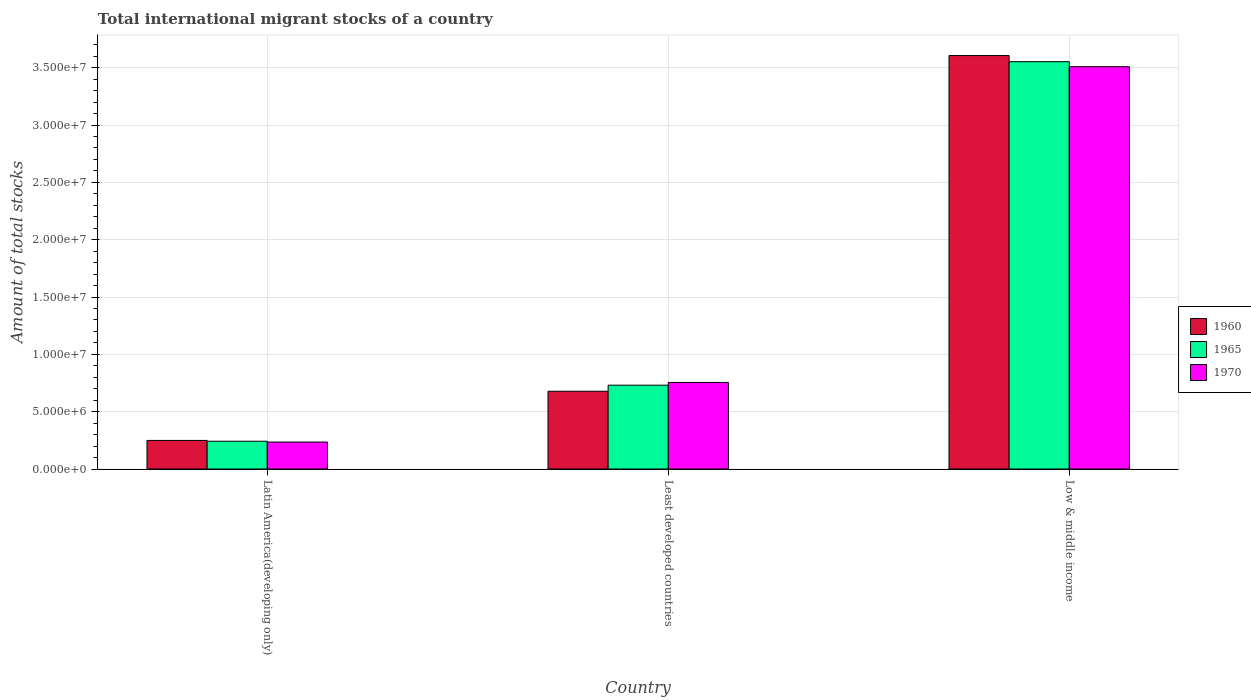Are the number of bars on each tick of the X-axis equal?
Keep it short and to the point. Yes. What is the label of the 1st group of bars from the left?
Provide a short and direct response. Latin America(developing only). What is the amount of total stocks in in 1960 in Least developed countries?
Ensure brevity in your answer.  6.78e+06. Across all countries, what is the maximum amount of total stocks in in 1965?
Ensure brevity in your answer.  3.55e+07. Across all countries, what is the minimum amount of total stocks in in 1960?
Make the answer very short. 2.49e+06. In which country was the amount of total stocks in in 1970 maximum?
Your response must be concise. Low & middle income. In which country was the amount of total stocks in in 1965 minimum?
Provide a succinct answer. Latin America(developing only). What is the total amount of total stocks in in 1960 in the graph?
Provide a succinct answer. 4.53e+07. What is the difference between the amount of total stocks in in 1970 in Latin America(developing only) and that in Least developed countries?
Your response must be concise. -5.20e+06. What is the difference between the amount of total stocks in in 1965 in Low & middle income and the amount of total stocks in in 1970 in Latin America(developing only)?
Keep it short and to the point. 3.32e+07. What is the average amount of total stocks in in 1970 per country?
Your answer should be compact. 1.50e+07. What is the difference between the amount of total stocks in of/in 1965 and amount of total stocks in of/in 1970 in Low & middle income?
Keep it short and to the point. 4.38e+05. In how many countries, is the amount of total stocks in in 1960 greater than 15000000?
Give a very brief answer. 1. What is the ratio of the amount of total stocks in in 1965 in Least developed countries to that in Low & middle income?
Provide a short and direct response. 0.21. Is the amount of total stocks in in 1965 in Least developed countries less than that in Low & middle income?
Your answer should be compact. Yes. Is the difference between the amount of total stocks in in 1965 in Latin America(developing only) and Low & middle income greater than the difference between the amount of total stocks in in 1970 in Latin America(developing only) and Low & middle income?
Ensure brevity in your answer.  No. What is the difference between the highest and the second highest amount of total stocks in in 1970?
Keep it short and to the point. -2.75e+07. What is the difference between the highest and the lowest amount of total stocks in in 1960?
Offer a terse response. 3.36e+07. Is the sum of the amount of total stocks in in 1965 in Latin America(developing only) and Least developed countries greater than the maximum amount of total stocks in in 1960 across all countries?
Make the answer very short. No. What does the 2nd bar from the left in Low & middle income represents?
Offer a very short reply. 1965. Is it the case that in every country, the sum of the amount of total stocks in in 1970 and amount of total stocks in in 1965 is greater than the amount of total stocks in in 1960?
Make the answer very short. Yes. How many countries are there in the graph?
Your answer should be compact. 3. Does the graph contain any zero values?
Your response must be concise. No. What is the title of the graph?
Provide a succinct answer. Total international migrant stocks of a country. Does "1987" appear as one of the legend labels in the graph?
Your answer should be very brief. No. What is the label or title of the Y-axis?
Your answer should be very brief. Amount of total stocks. What is the Amount of total stocks of 1960 in Latin America(developing only)?
Your answer should be very brief. 2.49e+06. What is the Amount of total stocks of 1965 in Latin America(developing only)?
Your response must be concise. 2.42e+06. What is the Amount of total stocks in 1970 in Latin America(developing only)?
Your answer should be very brief. 2.35e+06. What is the Amount of total stocks of 1960 in Least developed countries?
Your answer should be compact. 6.78e+06. What is the Amount of total stocks in 1965 in Least developed countries?
Your answer should be very brief. 7.31e+06. What is the Amount of total stocks in 1970 in Least developed countries?
Your answer should be very brief. 7.55e+06. What is the Amount of total stocks of 1960 in Low & middle income?
Offer a terse response. 3.61e+07. What is the Amount of total stocks of 1965 in Low & middle income?
Keep it short and to the point. 3.55e+07. What is the Amount of total stocks in 1970 in Low & middle income?
Offer a terse response. 3.51e+07. Across all countries, what is the maximum Amount of total stocks in 1960?
Your response must be concise. 3.61e+07. Across all countries, what is the maximum Amount of total stocks of 1965?
Offer a terse response. 3.55e+07. Across all countries, what is the maximum Amount of total stocks of 1970?
Your answer should be very brief. 3.51e+07. Across all countries, what is the minimum Amount of total stocks in 1960?
Your answer should be very brief. 2.49e+06. Across all countries, what is the minimum Amount of total stocks in 1965?
Ensure brevity in your answer.  2.42e+06. Across all countries, what is the minimum Amount of total stocks of 1970?
Ensure brevity in your answer.  2.35e+06. What is the total Amount of total stocks in 1960 in the graph?
Provide a short and direct response. 4.53e+07. What is the total Amount of total stocks in 1965 in the graph?
Give a very brief answer. 4.53e+07. What is the total Amount of total stocks in 1970 in the graph?
Give a very brief answer. 4.50e+07. What is the difference between the Amount of total stocks of 1960 in Latin America(developing only) and that in Least developed countries?
Offer a very short reply. -4.29e+06. What is the difference between the Amount of total stocks in 1965 in Latin America(developing only) and that in Least developed countries?
Keep it short and to the point. -4.89e+06. What is the difference between the Amount of total stocks in 1970 in Latin America(developing only) and that in Least developed countries?
Your answer should be compact. -5.20e+06. What is the difference between the Amount of total stocks in 1960 in Latin America(developing only) and that in Low & middle income?
Offer a very short reply. -3.36e+07. What is the difference between the Amount of total stocks in 1965 in Latin America(developing only) and that in Low & middle income?
Give a very brief answer. -3.31e+07. What is the difference between the Amount of total stocks of 1970 in Latin America(developing only) and that in Low & middle income?
Give a very brief answer. -3.27e+07. What is the difference between the Amount of total stocks of 1960 in Least developed countries and that in Low & middle income?
Your response must be concise. -2.93e+07. What is the difference between the Amount of total stocks in 1965 in Least developed countries and that in Low & middle income?
Provide a succinct answer. -2.82e+07. What is the difference between the Amount of total stocks of 1970 in Least developed countries and that in Low & middle income?
Provide a succinct answer. -2.75e+07. What is the difference between the Amount of total stocks in 1960 in Latin America(developing only) and the Amount of total stocks in 1965 in Least developed countries?
Keep it short and to the point. -4.82e+06. What is the difference between the Amount of total stocks in 1960 in Latin America(developing only) and the Amount of total stocks in 1970 in Least developed countries?
Your answer should be very brief. -5.06e+06. What is the difference between the Amount of total stocks in 1965 in Latin America(developing only) and the Amount of total stocks in 1970 in Least developed countries?
Keep it short and to the point. -5.13e+06. What is the difference between the Amount of total stocks in 1960 in Latin America(developing only) and the Amount of total stocks in 1965 in Low & middle income?
Offer a very short reply. -3.30e+07. What is the difference between the Amount of total stocks of 1960 in Latin America(developing only) and the Amount of total stocks of 1970 in Low & middle income?
Provide a succinct answer. -3.26e+07. What is the difference between the Amount of total stocks in 1965 in Latin America(developing only) and the Amount of total stocks in 1970 in Low & middle income?
Your response must be concise. -3.27e+07. What is the difference between the Amount of total stocks in 1960 in Least developed countries and the Amount of total stocks in 1965 in Low & middle income?
Your answer should be compact. -2.87e+07. What is the difference between the Amount of total stocks in 1960 in Least developed countries and the Amount of total stocks in 1970 in Low & middle income?
Keep it short and to the point. -2.83e+07. What is the difference between the Amount of total stocks of 1965 in Least developed countries and the Amount of total stocks of 1970 in Low & middle income?
Offer a terse response. -2.78e+07. What is the average Amount of total stocks of 1960 per country?
Your response must be concise. 1.51e+07. What is the average Amount of total stocks of 1965 per country?
Your answer should be compact. 1.51e+07. What is the average Amount of total stocks in 1970 per country?
Provide a short and direct response. 1.50e+07. What is the difference between the Amount of total stocks of 1960 and Amount of total stocks of 1965 in Latin America(developing only)?
Your response must be concise. 7.11e+04. What is the difference between the Amount of total stocks in 1960 and Amount of total stocks in 1970 in Latin America(developing only)?
Provide a short and direct response. 1.39e+05. What is the difference between the Amount of total stocks in 1965 and Amount of total stocks in 1970 in Latin America(developing only)?
Your answer should be compact. 6.84e+04. What is the difference between the Amount of total stocks of 1960 and Amount of total stocks of 1965 in Least developed countries?
Your answer should be very brief. -5.28e+05. What is the difference between the Amount of total stocks of 1960 and Amount of total stocks of 1970 in Least developed countries?
Make the answer very short. -7.68e+05. What is the difference between the Amount of total stocks in 1965 and Amount of total stocks in 1970 in Least developed countries?
Provide a short and direct response. -2.40e+05. What is the difference between the Amount of total stocks in 1960 and Amount of total stocks in 1965 in Low & middle income?
Your response must be concise. 5.35e+05. What is the difference between the Amount of total stocks of 1960 and Amount of total stocks of 1970 in Low & middle income?
Keep it short and to the point. 9.73e+05. What is the difference between the Amount of total stocks of 1965 and Amount of total stocks of 1970 in Low & middle income?
Your answer should be compact. 4.38e+05. What is the ratio of the Amount of total stocks in 1960 in Latin America(developing only) to that in Least developed countries?
Your answer should be compact. 0.37. What is the ratio of the Amount of total stocks in 1965 in Latin America(developing only) to that in Least developed countries?
Offer a very short reply. 0.33. What is the ratio of the Amount of total stocks of 1970 in Latin America(developing only) to that in Least developed countries?
Your response must be concise. 0.31. What is the ratio of the Amount of total stocks in 1960 in Latin America(developing only) to that in Low & middle income?
Ensure brevity in your answer.  0.07. What is the ratio of the Amount of total stocks of 1965 in Latin America(developing only) to that in Low & middle income?
Make the answer very short. 0.07. What is the ratio of the Amount of total stocks of 1970 in Latin America(developing only) to that in Low & middle income?
Provide a succinct answer. 0.07. What is the ratio of the Amount of total stocks of 1960 in Least developed countries to that in Low & middle income?
Provide a short and direct response. 0.19. What is the ratio of the Amount of total stocks of 1965 in Least developed countries to that in Low & middle income?
Offer a terse response. 0.21. What is the ratio of the Amount of total stocks of 1970 in Least developed countries to that in Low & middle income?
Provide a succinct answer. 0.22. What is the difference between the highest and the second highest Amount of total stocks in 1960?
Ensure brevity in your answer.  2.93e+07. What is the difference between the highest and the second highest Amount of total stocks in 1965?
Ensure brevity in your answer.  2.82e+07. What is the difference between the highest and the second highest Amount of total stocks in 1970?
Provide a succinct answer. 2.75e+07. What is the difference between the highest and the lowest Amount of total stocks of 1960?
Your answer should be very brief. 3.36e+07. What is the difference between the highest and the lowest Amount of total stocks in 1965?
Your answer should be very brief. 3.31e+07. What is the difference between the highest and the lowest Amount of total stocks in 1970?
Provide a succinct answer. 3.27e+07. 